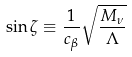Convert formula to latex. <formula><loc_0><loc_0><loc_500><loc_500>\sin \zeta \equiv \frac { 1 } { c _ { \beta } } \sqrt { \frac { M _ { \nu } } { \Lambda } }</formula> 